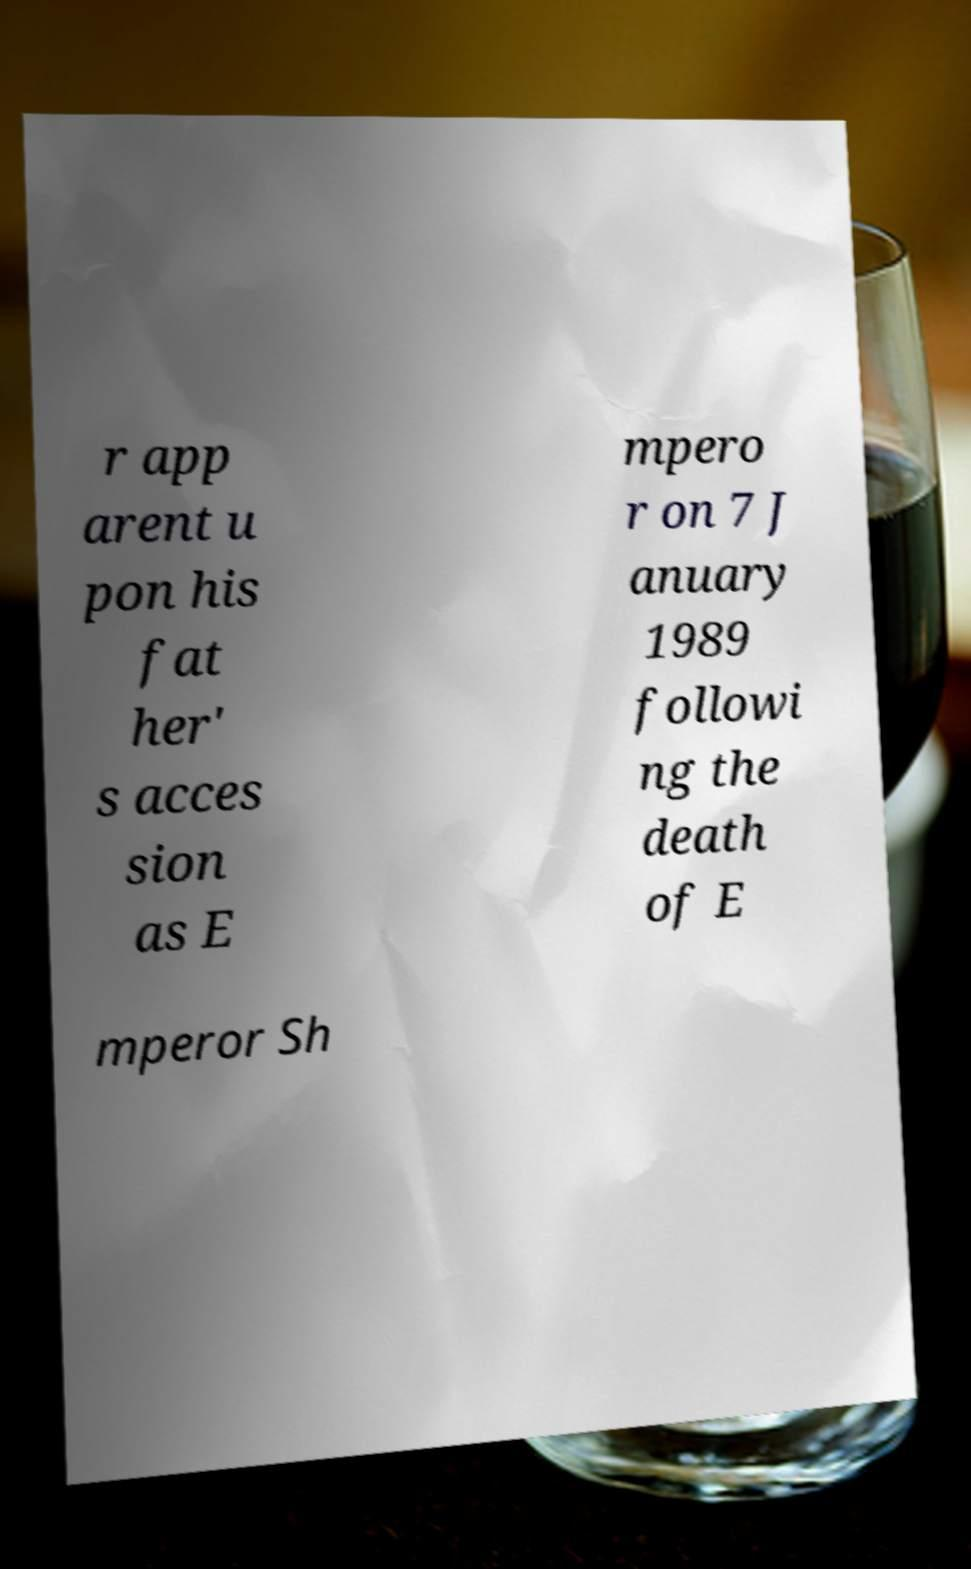Could you assist in decoding the text presented in this image and type it out clearly? r app arent u pon his fat her' s acces sion as E mpero r on 7 J anuary 1989 followi ng the death of E mperor Sh 